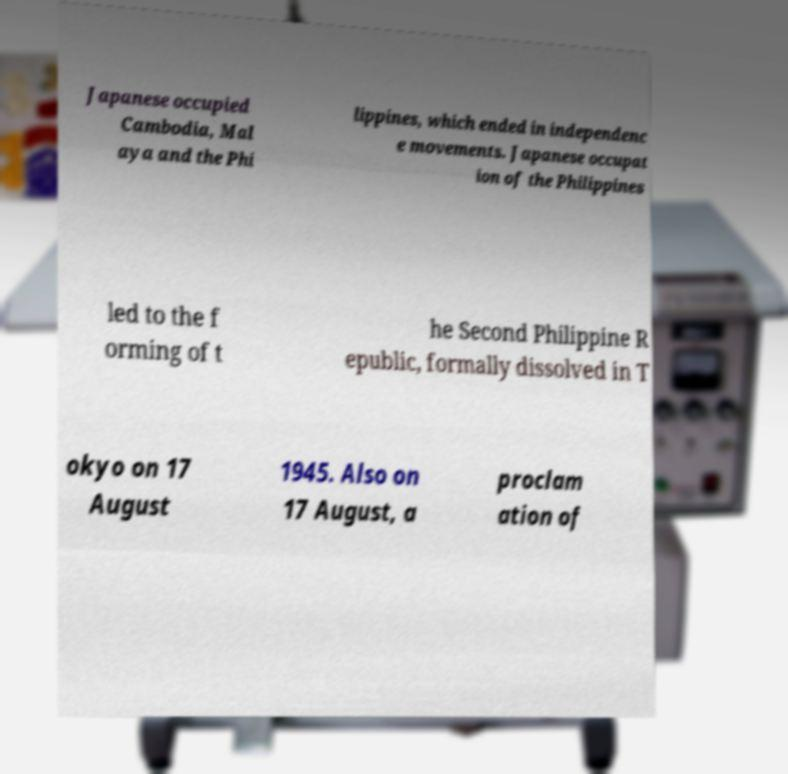Please identify and transcribe the text found in this image. Japanese occupied Cambodia, Mal aya and the Phi lippines, which ended in independenc e movements. Japanese occupat ion of the Philippines led to the f orming of t he Second Philippine R epublic, formally dissolved in T okyo on 17 August 1945. Also on 17 August, a proclam ation of 